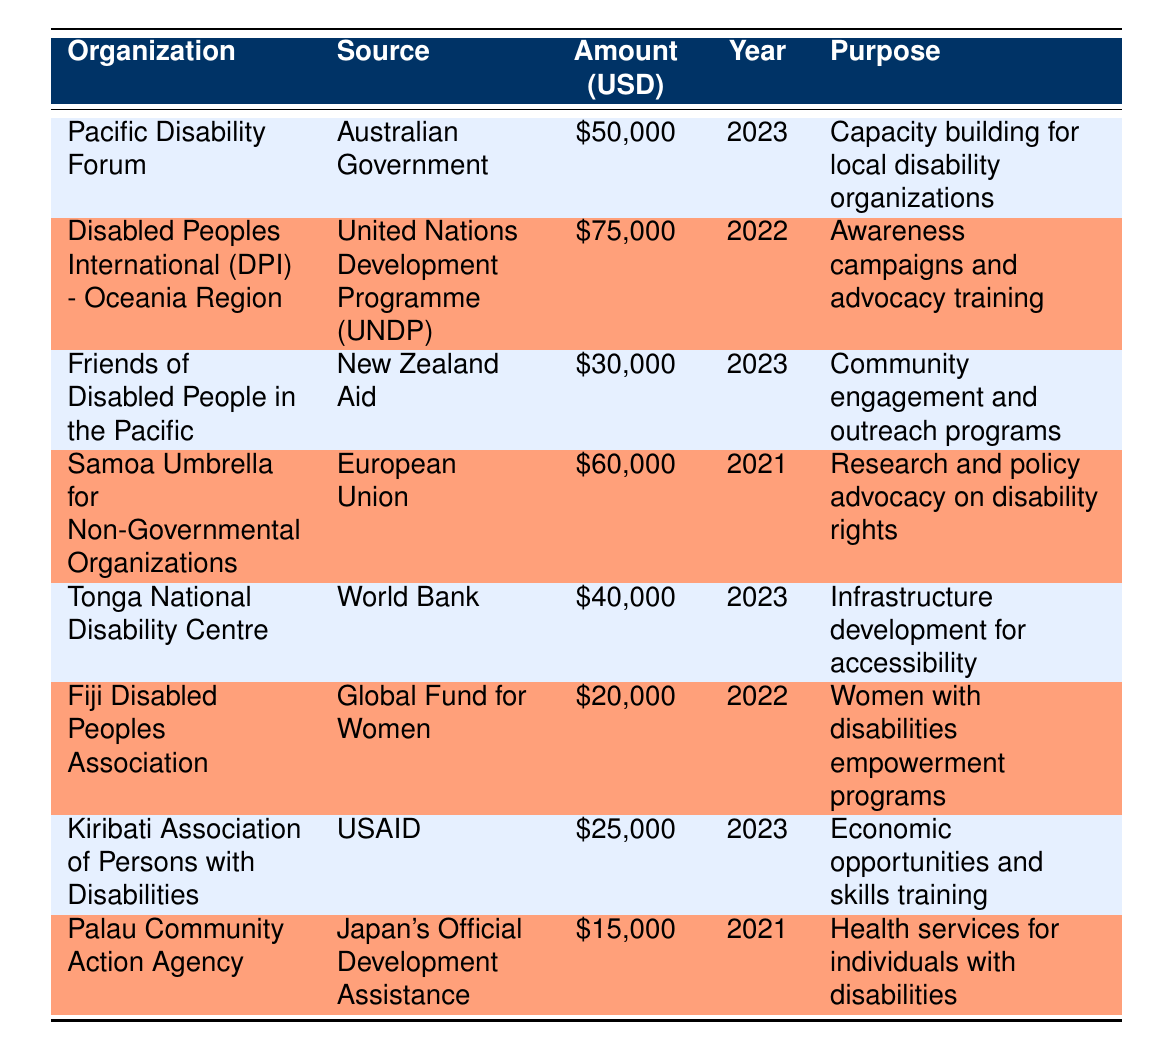What is the total funding amount awarded in 2023? To find the total funding awarded in 2023, I need to identify all organizations that received funding that year. The relevant entries in the table are Pacific Disability Forum ($50,000), Friends of Disabled People in the Pacific ($30,000), Tonga National Disability Centre ($40,000), and Kiribati Association of Persons with Disabilities ($25,000). Summing these amounts: 50,000 + 30,000 + 40,000 + 25,000 = 145,000.
Answer: 145000 What is the purpose of the funding provided by the European Union? I can find the relevant entry in the table by looking for the source listed as European Union. That entry shows that the purpose of funding from the European Union (to the Samoa Umbrella for Non-Governmental Organizations for $60,000 in 2021) is "Research and policy advocacy on disability rights."
Answer: Research and policy advocacy on disability rights Which organization received the least amount of funding, and how much was it? I need to review the funding amounts listed in the table. After going through all entries, Palau Community Action Agency received the least amount of funding, which is $15,000.
Answer: Palau Community Action Agency, 15000 Did Fiji Disabled Peoples Association receive more funding than Kiribati Association of Persons with Disabilities? The funding amount for Fiji Disabled Peoples Association is $20,000, while for Kiribati Association of Persons with Disabilities, it is $25,000. Since $20,000 is less than $25,000, the answer is no.
Answer: No What is the average funding amount across all listed organizations? To calculate the average funding amount, I will sum up all the funding amounts: 50,000 + 75,000 + 30,000 + 60,000 + 40,000 + 20,000 + 25,000 + 15,000 = 315,000. There are 8 organizations, so the average is 315,000 divided by 8, which equals 39,375.
Answer: 39375 Which organization received funding from the World Bank, and for what purpose? Referring to the table, the entry for the World Bank shows that the Tonga National Disability Centre received funding of $40,000 in 2023 for "Infrastructure development for accessibility."
Answer: Tonga National Disability Centre, Infrastructure development for accessibility Was the funding from USAID aimed at skills training? The funding provided by USAID is for the Kiribati Association of Persons with Disabilities with a purpose of "Economic opportunities and skills training." Since skills training is mentioned in the purpose, the answer is yes.
Answer: Yes What was the total amount of funding from sources in 2022? To find the total amount of funding from 2022, I will add the relevant amounts from the table for that year. The two entries for 2022 are Disabled Peoples International ($75,000) and Fiji Disabled Peoples Association ($20,000). Adding these gives a total of 75,000 + 20,000 = 95,000.
Answer: 95000 